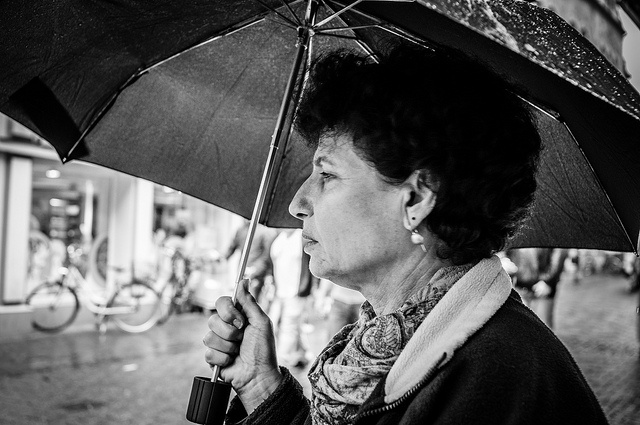Describe the objects in this image and their specific colors. I can see people in black, darkgray, gray, and lightgray tones, umbrella in black, gray, darkgray, and lightgray tones, bicycle in black, lightgray, darkgray, and gray tones, and people in black, darkgray, lightgray, and gray tones in this image. 